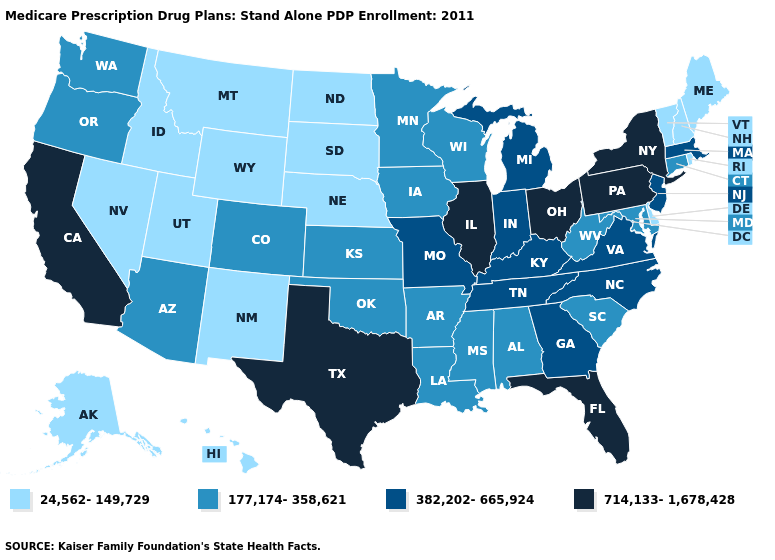What is the lowest value in the Northeast?
Keep it brief. 24,562-149,729. What is the value of Nebraska?
Keep it brief. 24,562-149,729. What is the value of Colorado?
Short answer required. 177,174-358,621. What is the lowest value in the USA?
Short answer required. 24,562-149,729. What is the highest value in the West ?
Concise answer only. 714,133-1,678,428. What is the value of Idaho?
Quick response, please. 24,562-149,729. Which states have the lowest value in the USA?
Quick response, please. Alaska, Delaware, Hawaii, Idaho, Maine, Montana, North Dakota, Nebraska, New Hampshire, New Mexico, Nevada, Rhode Island, South Dakota, Utah, Vermont, Wyoming. What is the highest value in the USA?
Be succinct. 714,133-1,678,428. Does Alaska have a lower value than Washington?
Concise answer only. Yes. Name the states that have a value in the range 177,174-358,621?
Be succinct. Alabama, Arkansas, Arizona, Colorado, Connecticut, Iowa, Kansas, Louisiana, Maryland, Minnesota, Mississippi, Oklahoma, Oregon, South Carolina, Washington, Wisconsin, West Virginia. What is the value of Arizona?
Concise answer only. 177,174-358,621. Name the states that have a value in the range 24,562-149,729?
Write a very short answer. Alaska, Delaware, Hawaii, Idaho, Maine, Montana, North Dakota, Nebraska, New Hampshire, New Mexico, Nevada, Rhode Island, South Dakota, Utah, Vermont, Wyoming. Name the states that have a value in the range 382,202-665,924?
Concise answer only. Georgia, Indiana, Kentucky, Massachusetts, Michigan, Missouri, North Carolina, New Jersey, Tennessee, Virginia. What is the highest value in states that border South Carolina?
Keep it brief. 382,202-665,924. Does the map have missing data?
Concise answer only. No. 